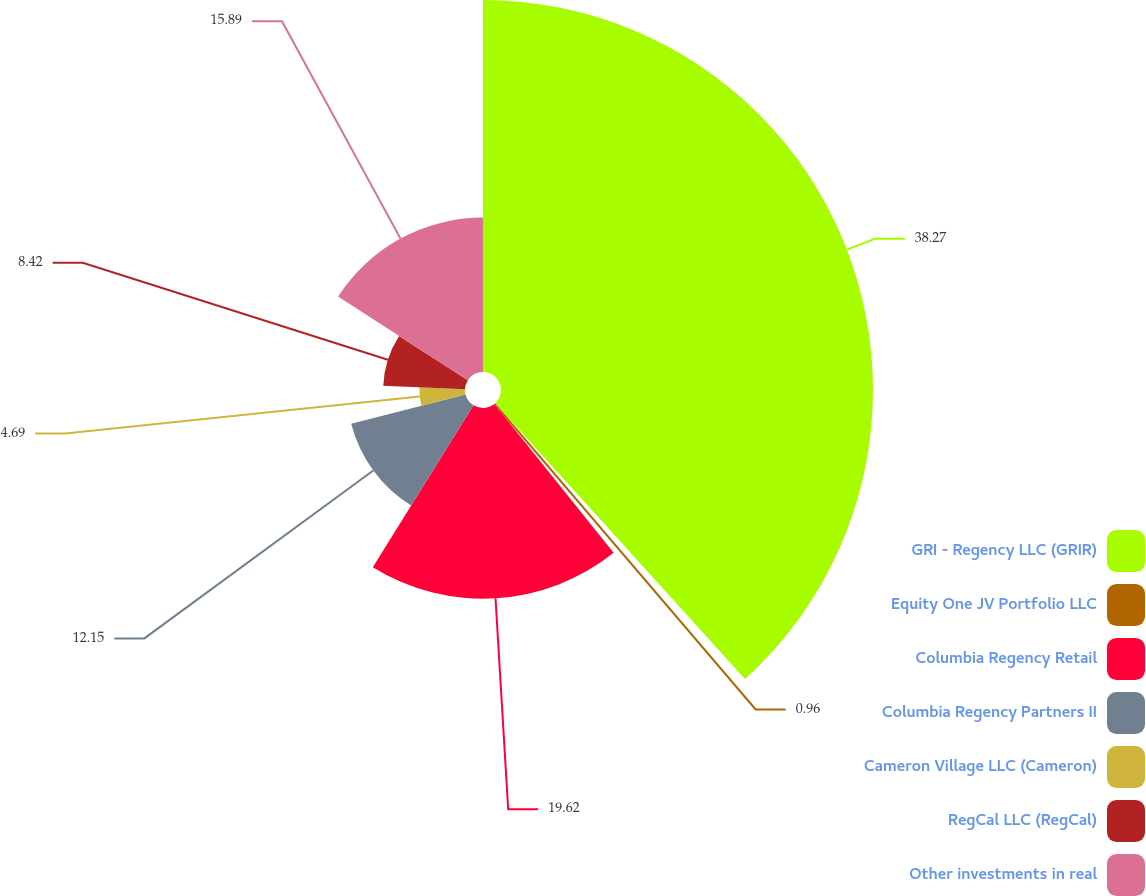Convert chart to OTSL. <chart><loc_0><loc_0><loc_500><loc_500><pie_chart><fcel>GRI - Regency LLC (GRIR)<fcel>Equity One JV Portfolio LLC<fcel>Columbia Regency Retail<fcel>Columbia Regency Partners II<fcel>Cameron Village LLC (Cameron)<fcel>RegCal LLC (RegCal)<fcel>Other investments in real<nl><fcel>38.28%<fcel>0.96%<fcel>19.62%<fcel>12.15%<fcel>4.69%<fcel>8.42%<fcel>15.89%<nl></chart> 